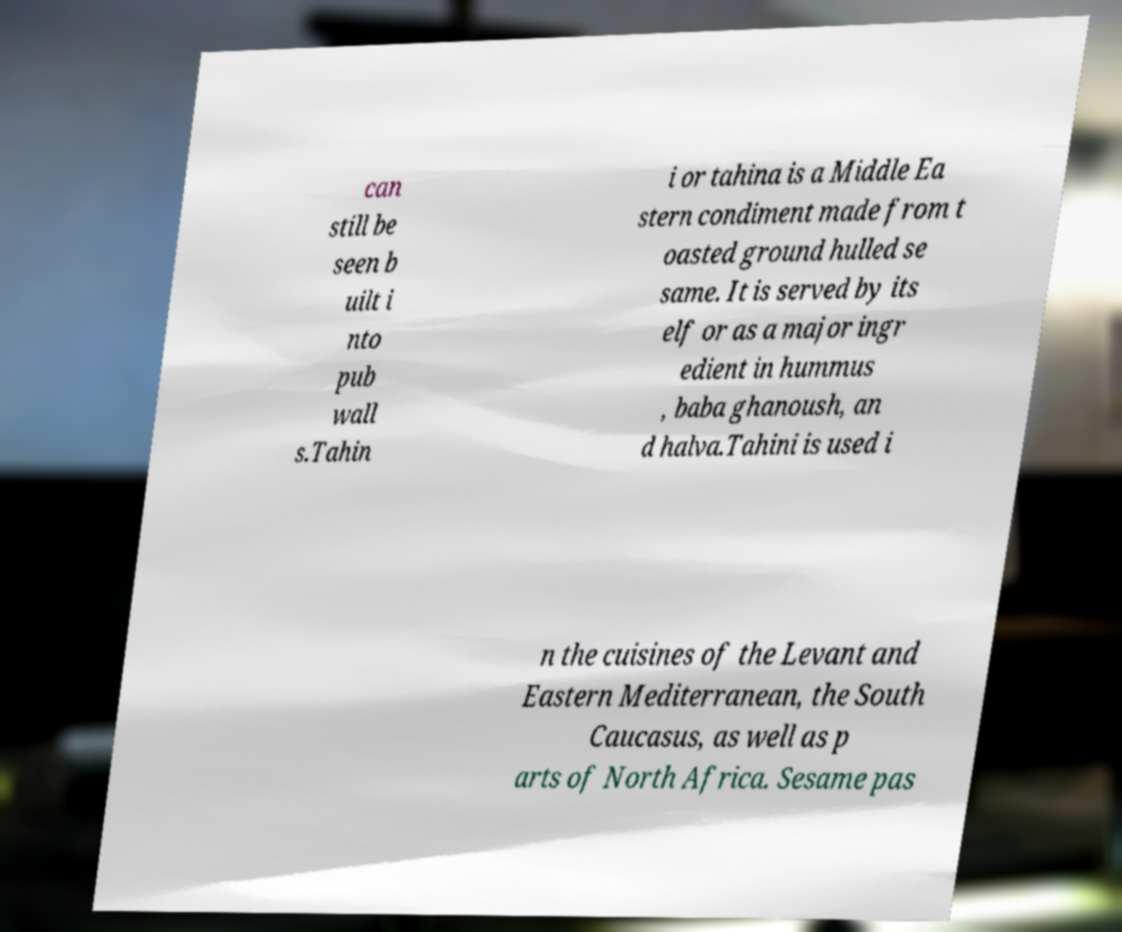There's text embedded in this image that I need extracted. Can you transcribe it verbatim? can still be seen b uilt i nto pub wall s.Tahin i or tahina is a Middle Ea stern condiment made from t oasted ground hulled se same. It is served by its elf or as a major ingr edient in hummus , baba ghanoush, an d halva.Tahini is used i n the cuisines of the Levant and Eastern Mediterranean, the South Caucasus, as well as p arts of North Africa. Sesame pas 